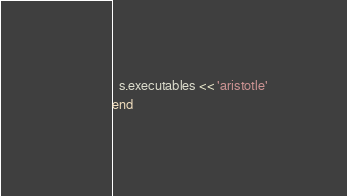<code> <loc_0><loc_0><loc_500><loc_500><_Ruby_>  s.executables << 'aristotle'
end
</code> 